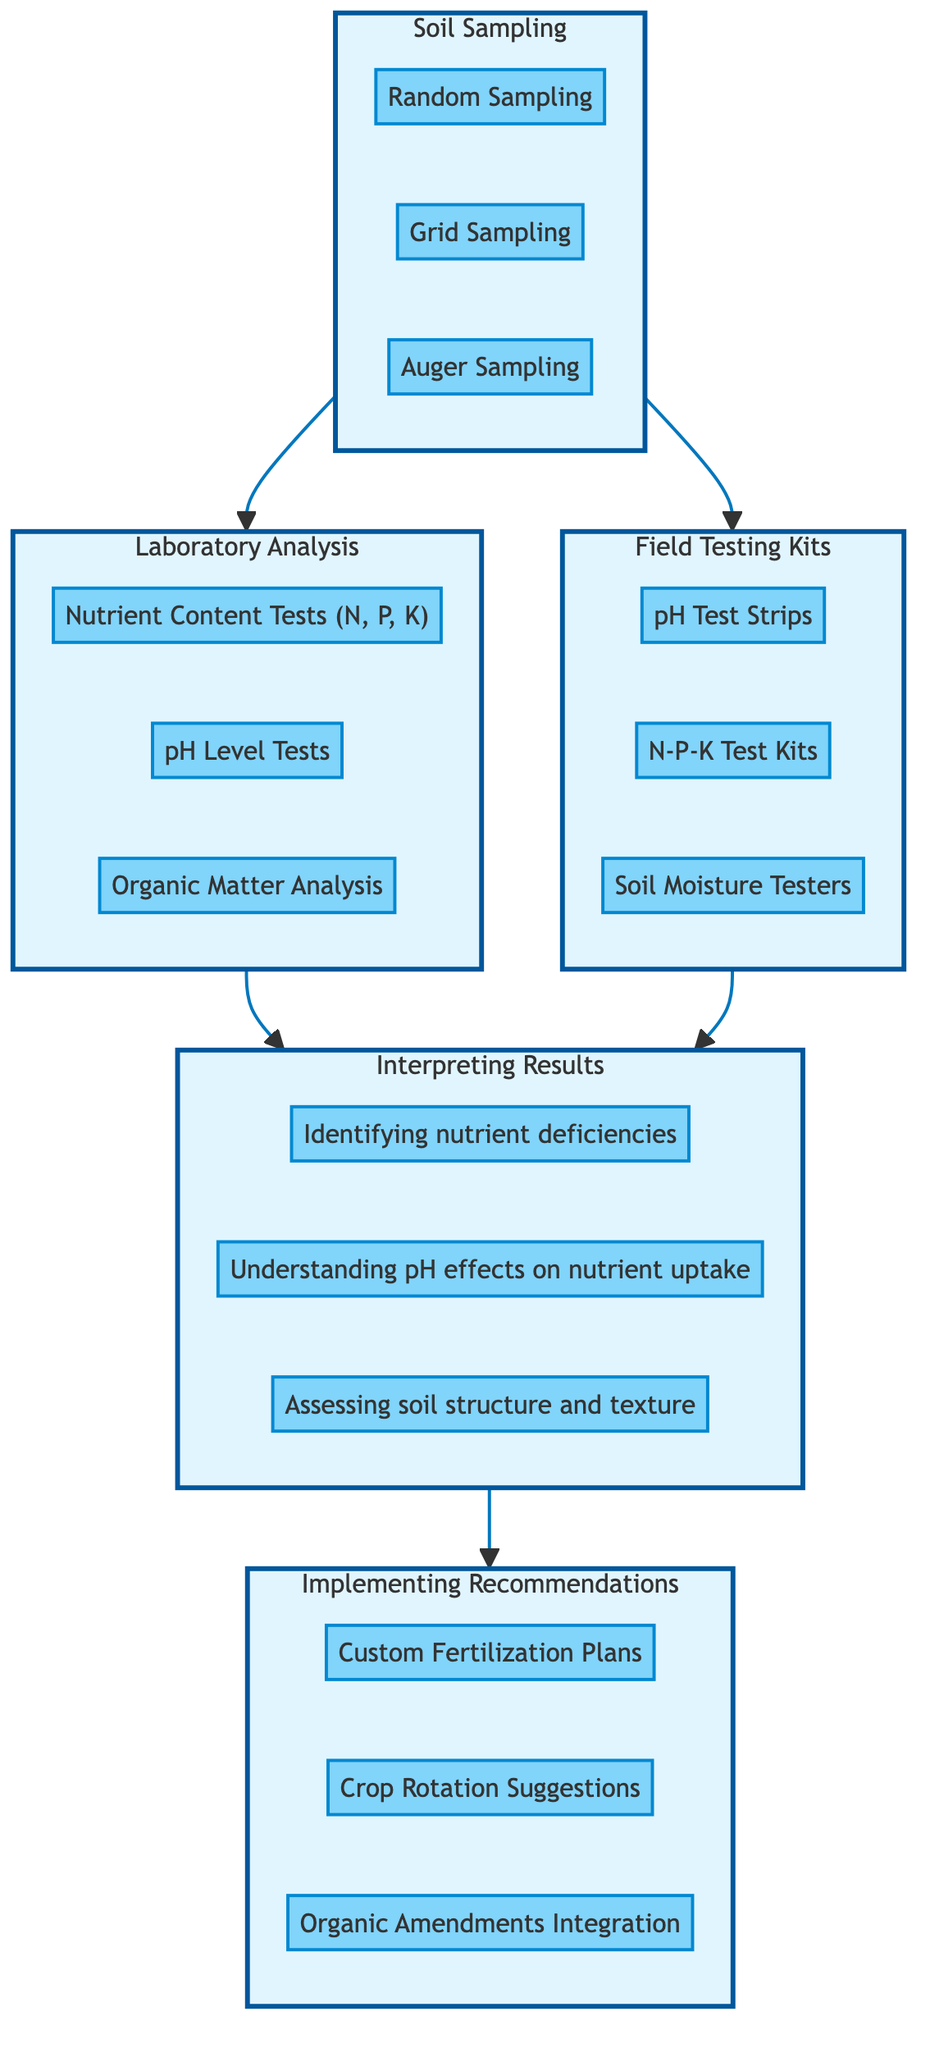What are the methods used for Soil Sampling? The diagram lists three specific methods under the "Soil Sampling" node: Random Sampling, Grid Sampling, and Auger Sampling. These methods detail how soil samples can be collected from various locations on the farm.
Answer: Random Sampling, Grid Sampling, Auger Sampling How many tests are conducted in Laboratory Analysis? In the "Laboratory Analysis" section, there are three tests mentioned: Nutrient Content Tests, pH Level Tests, and Organic Matter Analysis. This counts the number of distinct tests available in that step.
Answer: 3 What is the main focus of the "Interpreting Results" node? The "Interpreting Results" node describes the aspects involved in analyzing test data to determine soil health and nutrient availability. The key areas are identifying nutrient deficiencies, understanding pH effects on nutrient uptake, and assessing soil structure and texture.
Answer: Analyzing soil health and nutrient availability Which node leads to "Implementing Recommendations"? The flow in the diagram shows that "Interpreting Results" is the direct precursor to the "Implementing Recommendations" node. This means the analysis of test results leads to actions taken based on that analysis.
Answer: Interpreting Results What are the brands of Field Testing Kits mentioned? Under the "Field Testing Kits" node, three brands are listed: LaMotte Soil Test Kits, Hach Water Quality Test Kits, and Soil Savvy. These brands provide options for on-site soil testing.
Answer: LaMotte Soil Test Kits, Hach Water Quality Test Kits, Soil Savvy How does Laboratory Analysis relate to Soil Sampling? The diagram shows a direct link from "Soil Sampling" to "Laboratory Analysis," indicating that soil samples collected through various methods are sent for laboratory testing for comprehensive nutrient content analysis.
Answer: Laboratory Analysis What aspect of soil nutrients does the "Interpreting Results" node focus on? The "Interpreting Results" node includes aspects such as understanding pH effects on nutrient uptake, which directly relates to how soil chemistry affects nutrient availability to plants. This shows an important relationship between pH levels and the accessibility of nutrients in the soil.
Answer: Understanding pH effects on nutrient uptake Which testing method is characterized by speed and on-site use? The "Field Testing Kits" section is characterized by methods that allow for quick surface-level assessments of soil pH and nutrient levels, highlighting its utility for immediate testing needs.
Answer: Field Testing Kits 